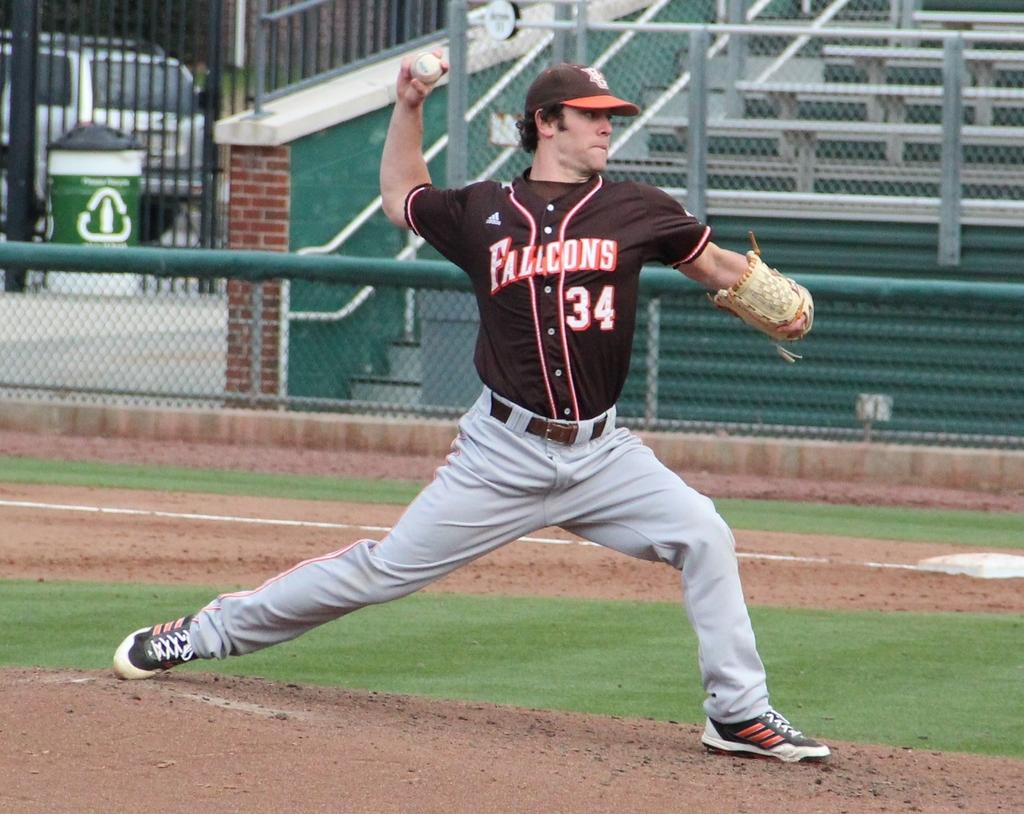<image>
Render a clear and concise summary of the photo. Player number 34 from the Falcons baseball team is throwing a pitch. 